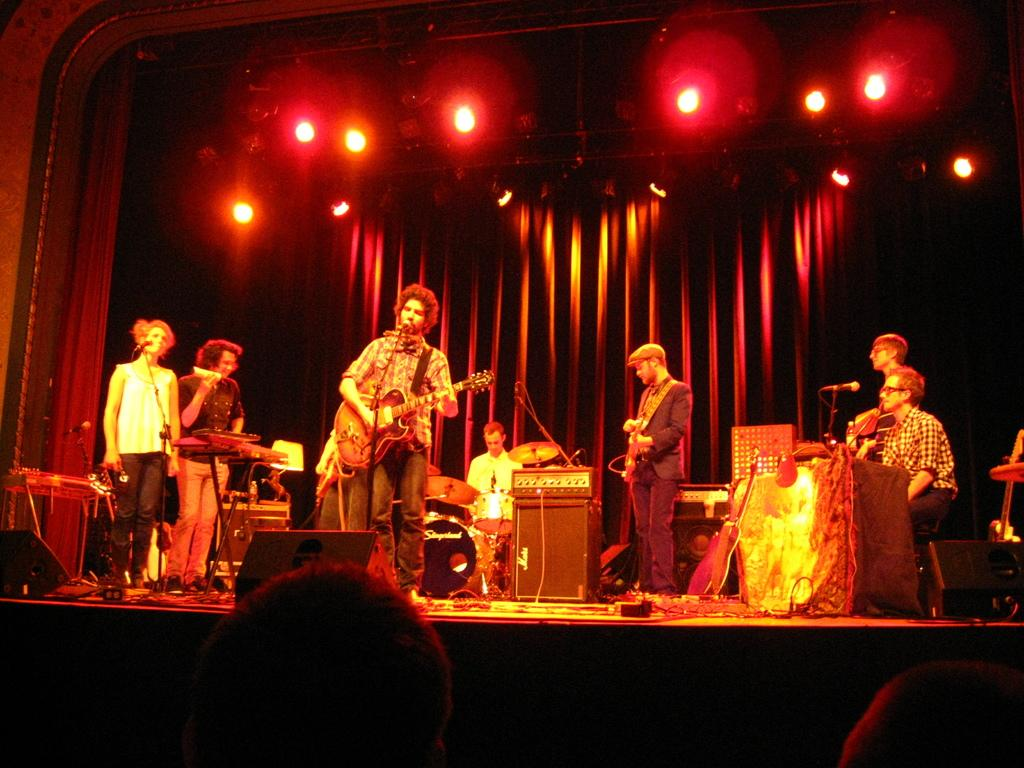Who or what can be seen in the image? There are people in the image. Where are the people located? The people are standing on a stage. What are the people doing on the stage? The people are playing musical instruments. How many rabbits can be seen playing musical instruments on the stage in the image? There are no rabbits present in the image; only people are playing musical instruments on the stage. 